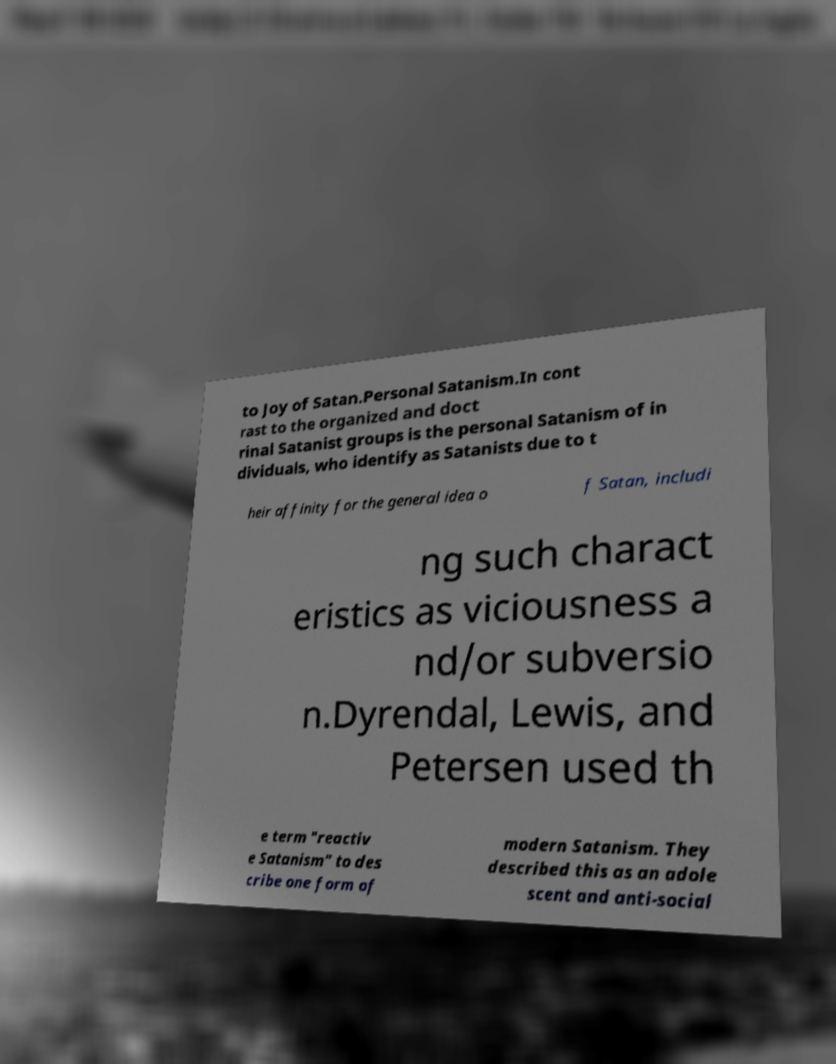Please identify and transcribe the text found in this image. to Joy of Satan.Personal Satanism.In cont rast to the organized and doct rinal Satanist groups is the personal Satanism of in dividuals, who identify as Satanists due to t heir affinity for the general idea o f Satan, includi ng such charact eristics as viciousness a nd/or subversio n.Dyrendal, Lewis, and Petersen used th e term "reactiv e Satanism" to des cribe one form of modern Satanism. They described this as an adole scent and anti-social 